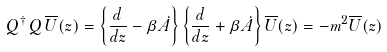Convert formula to latex. <formula><loc_0><loc_0><loc_500><loc_500>Q ^ { \dag } \, Q \, \overline { U } ( z ) = \left \{ \frac { d } { d z } - \beta \dot { A } \right \} \left \{ \frac { d } { d z } + \beta \dot { A } \right \} \overline { U } ( z ) = - m ^ { 2 } \overline { U } ( z )</formula> 